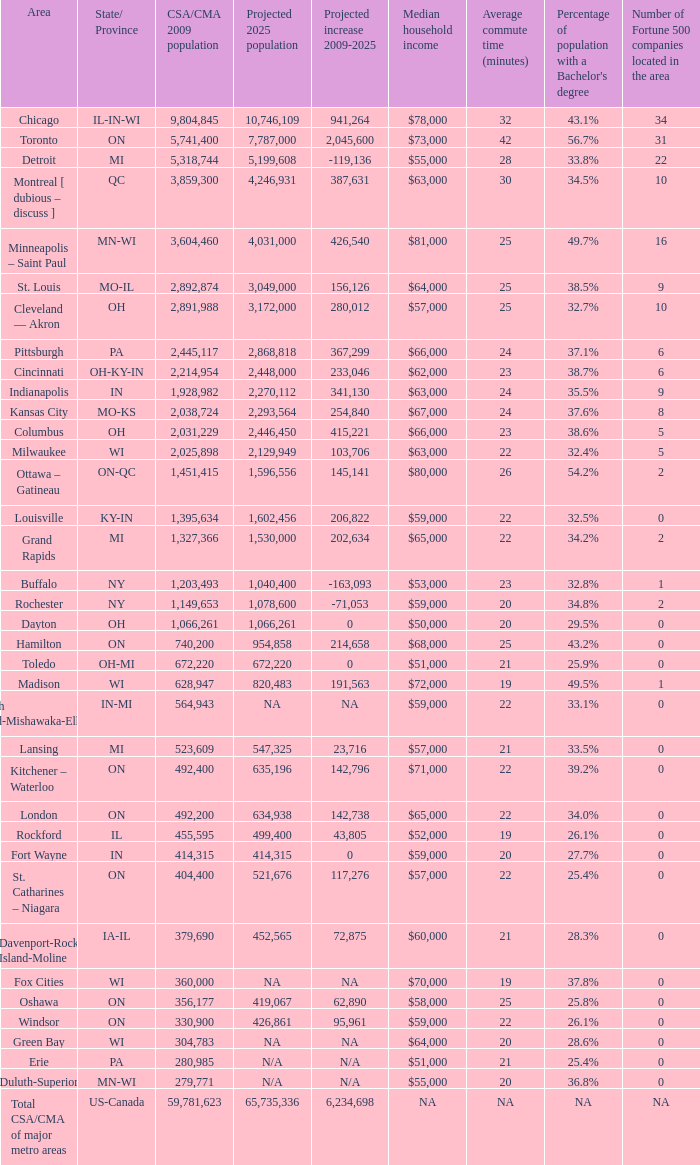What's the CSA/CMA Population in IA-IL? 379690.0. 